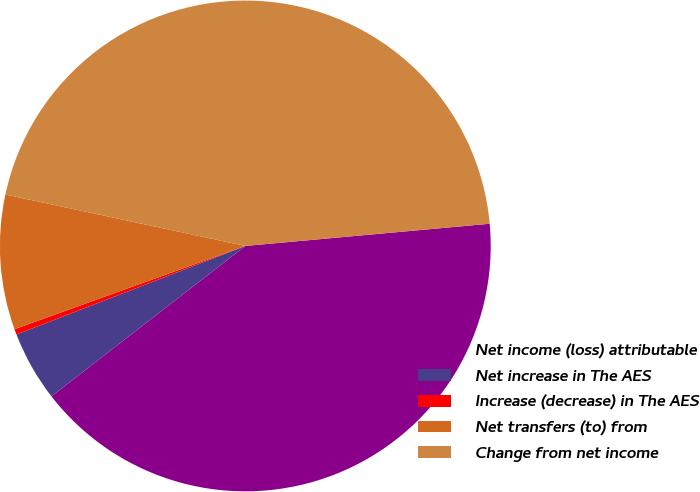<chart> <loc_0><loc_0><loc_500><loc_500><pie_chart><fcel>Net income (loss) attributable<fcel>Net increase in The AES<fcel>Increase (decrease) in The AES<fcel>Net transfers (to) from<fcel>Change from net income<nl><fcel>40.94%<fcel>4.62%<fcel>0.37%<fcel>8.87%<fcel>45.19%<nl></chart> 